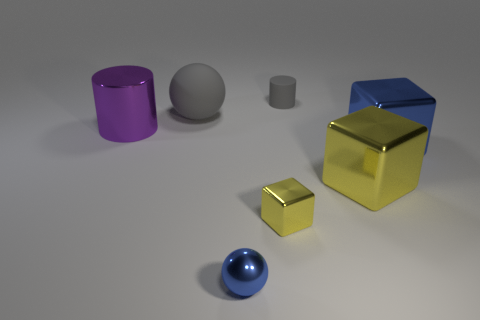Subtract all yellow cylinders. Subtract all blue spheres. How many cylinders are left? 2 Add 1 big things. How many objects exist? 8 Subtract all spheres. How many objects are left? 5 Subtract 0 red balls. How many objects are left? 7 Subtract all green cylinders. Subtract all small things. How many objects are left? 4 Add 5 small shiny spheres. How many small shiny spheres are left? 6 Add 4 small yellow rubber cubes. How many small yellow rubber cubes exist? 4 